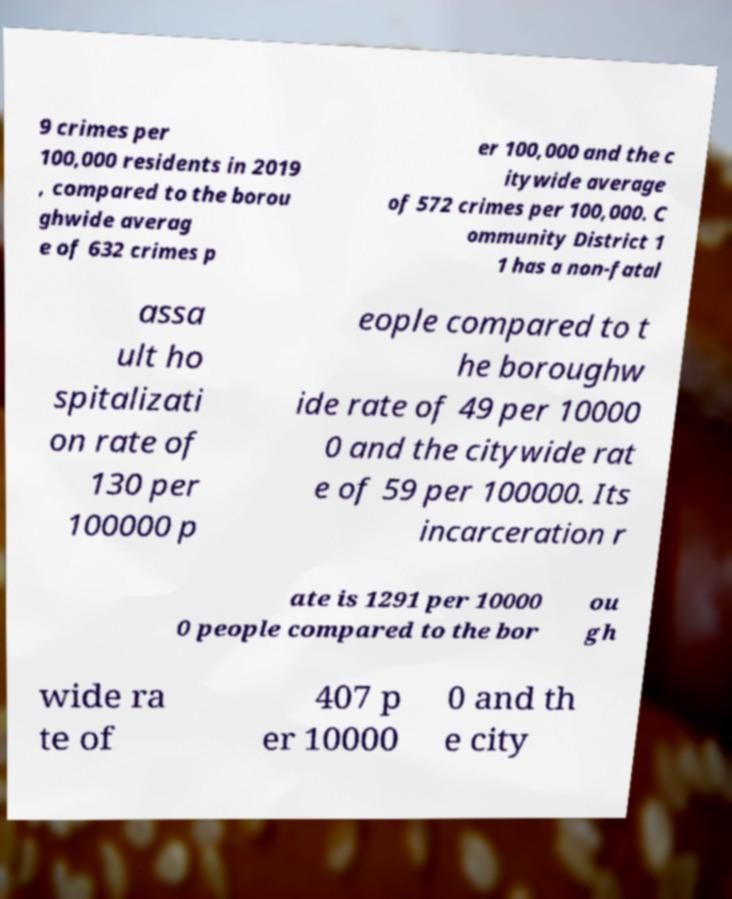Can you accurately transcribe the text from the provided image for me? 9 crimes per 100,000 residents in 2019 , compared to the borou ghwide averag e of 632 crimes p er 100,000 and the c itywide average of 572 crimes per 100,000. C ommunity District 1 1 has a non-fatal assa ult ho spitalizati on rate of 130 per 100000 p eople compared to t he boroughw ide rate of 49 per 10000 0 and the citywide rat e of 59 per 100000. Its incarceration r ate is 1291 per 10000 0 people compared to the bor ou gh wide ra te of 407 p er 10000 0 and th e city 